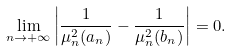<formula> <loc_0><loc_0><loc_500><loc_500>\lim _ { n \rightarrow + \infty } \left | \frac { 1 } { \mu _ { n } ^ { 2 } ( a _ { n } ) } - \frac { 1 } { \mu _ { n } ^ { 2 } ( b _ { n } ) } \right | = 0 .</formula> 